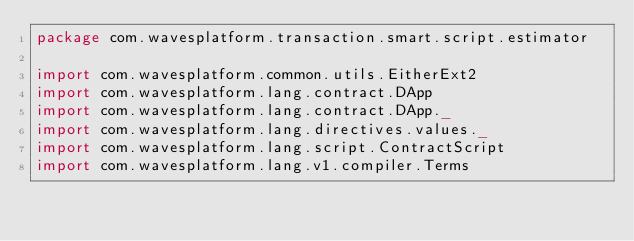<code> <loc_0><loc_0><loc_500><loc_500><_Scala_>package com.wavesplatform.transaction.smart.script.estimator

import com.wavesplatform.common.utils.EitherExt2
import com.wavesplatform.lang.contract.DApp
import com.wavesplatform.lang.contract.DApp._
import com.wavesplatform.lang.directives.values._
import com.wavesplatform.lang.script.ContractScript
import com.wavesplatform.lang.v1.compiler.Terms</code> 